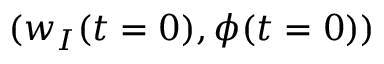<formula> <loc_0><loc_0><loc_500><loc_500>( w _ { I } ( t = 0 ) , \phi ( t = 0 ) )</formula> 